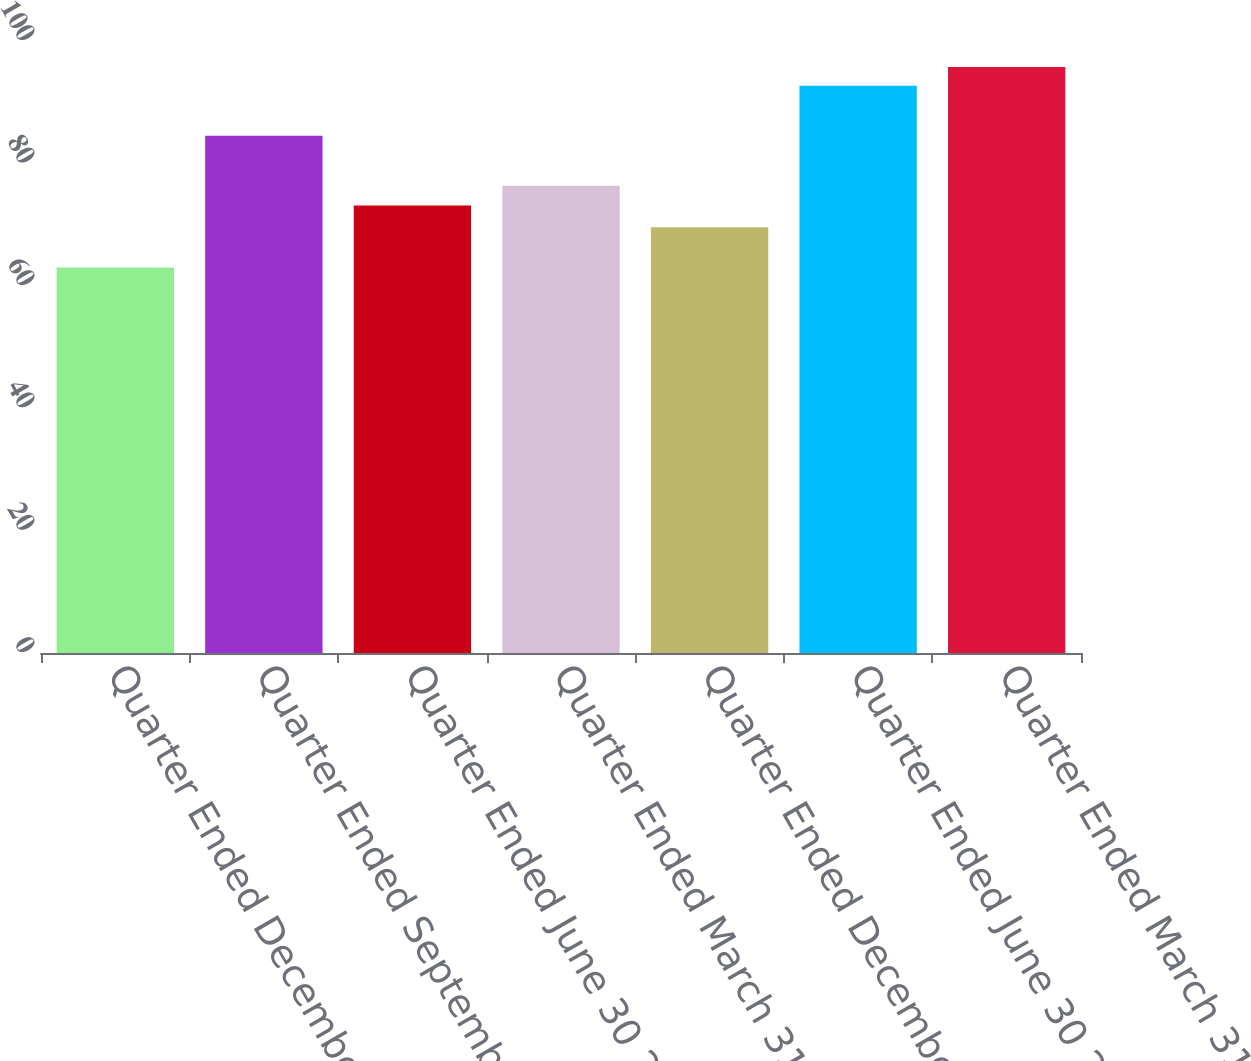<chart> <loc_0><loc_0><loc_500><loc_500><bar_chart><fcel>Quarter Ended December 31 2012<fcel>Quarter Ended September 30<fcel>Quarter Ended June 30 2012<fcel>Quarter Ended March 31 2012<fcel>Quarter Ended December 31 2011<fcel>Quarter Ended June 30 2011<fcel>Quarter Ended March 31 2011<nl><fcel>63<fcel>84.52<fcel>73.14<fcel>76.34<fcel>69.55<fcel>92.69<fcel>95.75<nl></chart> 